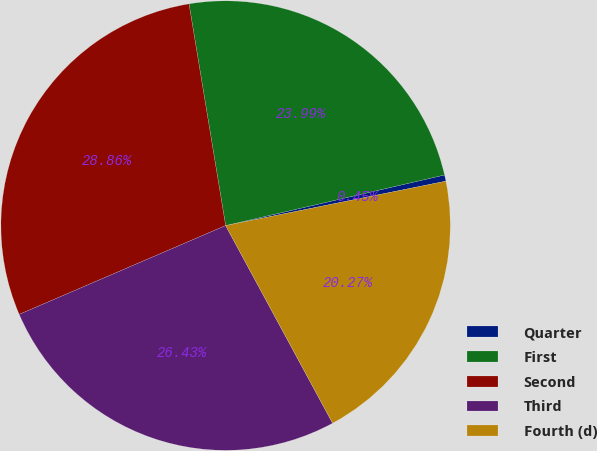Convert chart to OTSL. <chart><loc_0><loc_0><loc_500><loc_500><pie_chart><fcel>Quarter<fcel>First<fcel>Second<fcel>Third<fcel>Fourth (d)<nl><fcel>0.45%<fcel>23.99%<fcel>28.86%<fcel>26.43%<fcel>20.27%<nl></chart> 